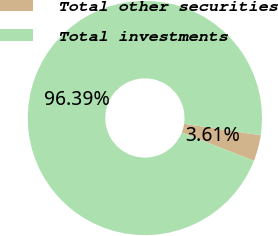Convert chart to OTSL. <chart><loc_0><loc_0><loc_500><loc_500><pie_chart><fcel>Total other securities<fcel>Total investments<nl><fcel>3.61%<fcel>96.39%<nl></chart> 